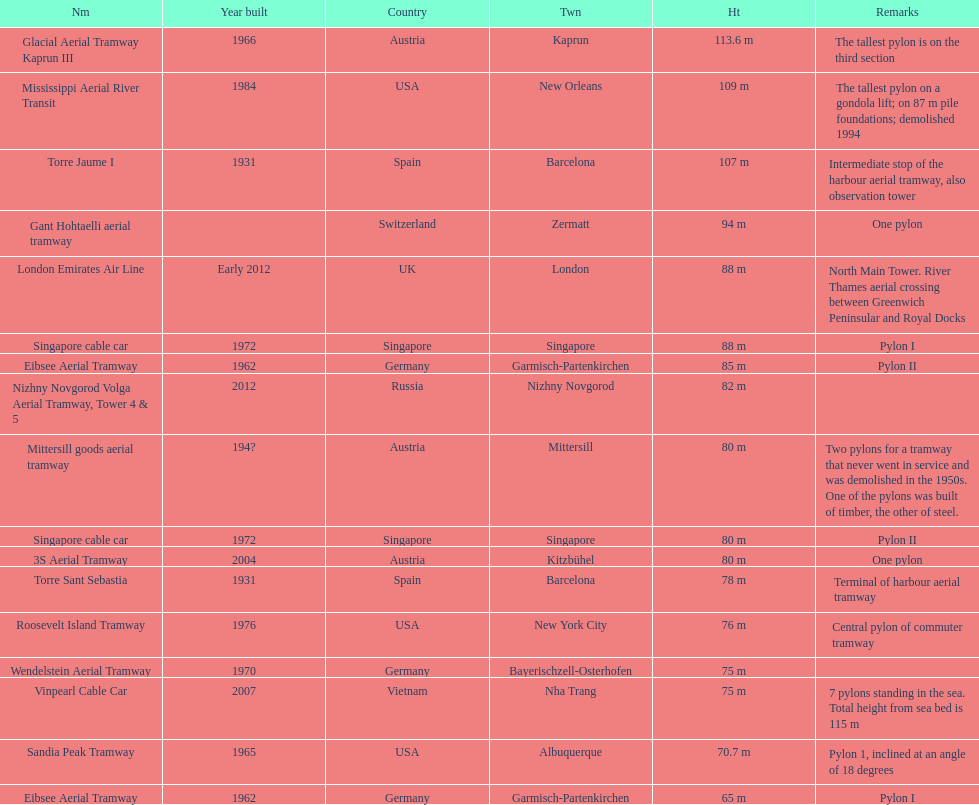How many pylons are in austria? 3. 